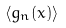Convert formula to latex. <formula><loc_0><loc_0><loc_500><loc_500>\langle g _ { n } ( x ) \rangle</formula> 